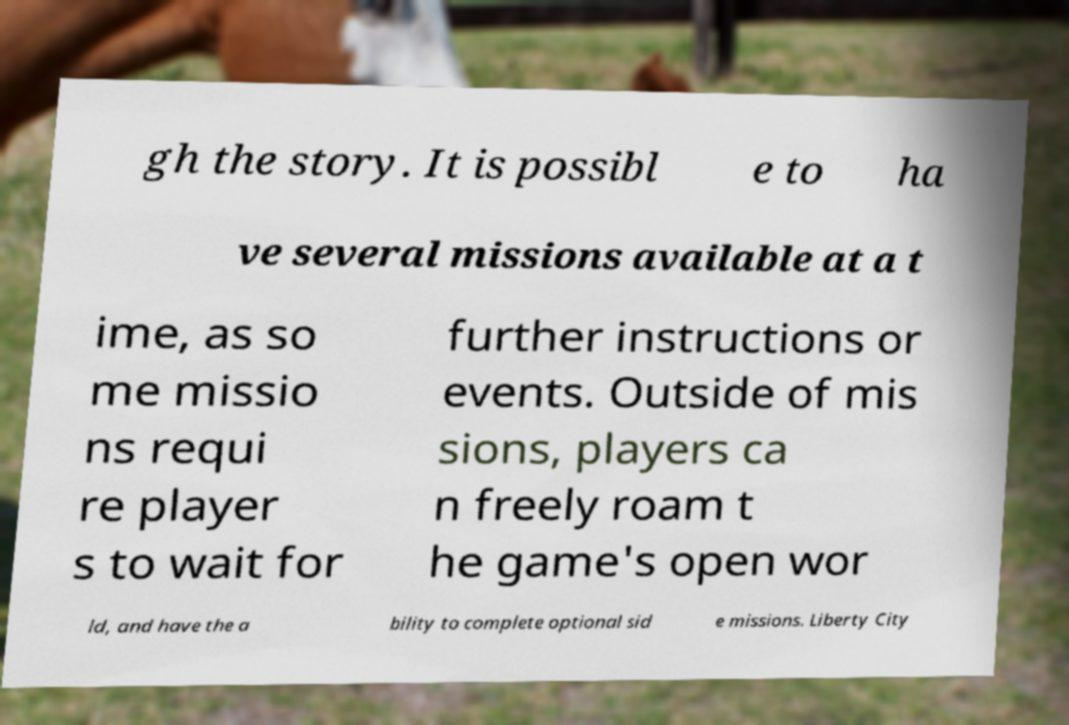Can you accurately transcribe the text from the provided image for me? gh the story. It is possibl e to ha ve several missions available at a t ime, as so me missio ns requi re player s to wait for further instructions or events. Outside of mis sions, players ca n freely roam t he game's open wor ld, and have the a bility to complete optional sid e missions. Liberty City 